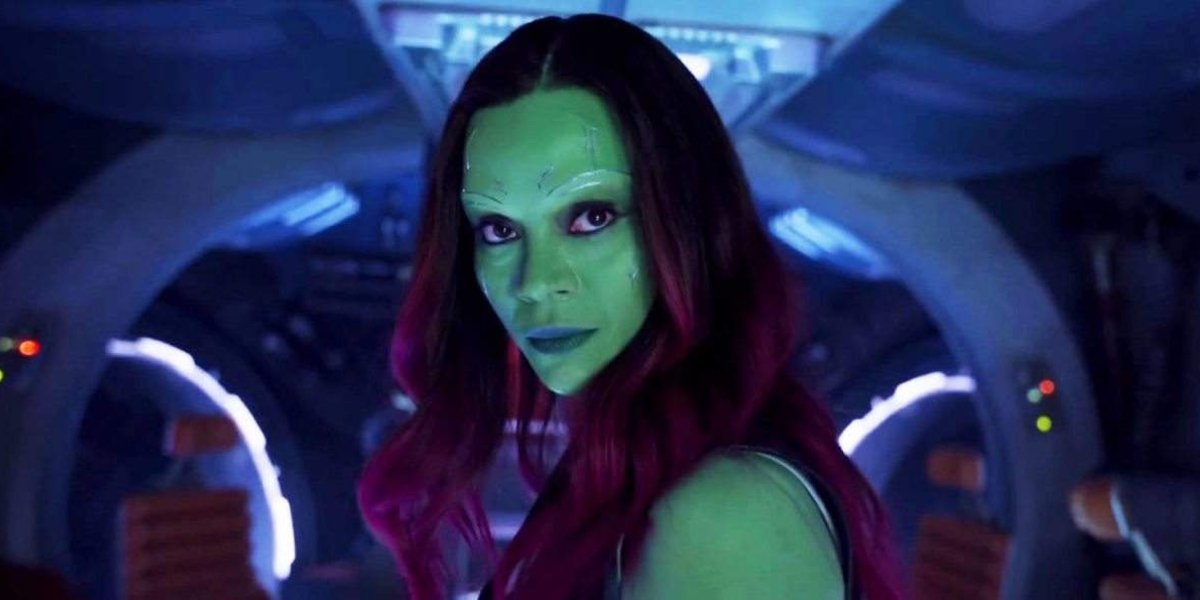What do the colors in the image suggest about the genre or theme of the situation? The dominant green skin tone of the character, combined with the contrasting red hair and the spaceship's ambient blue lighting, contributes to a futuristic and otherworldly feel. It implies a science fiction theme, where the norm is challenged by elements of space exploration, advanced technology, and potentially alien races. 